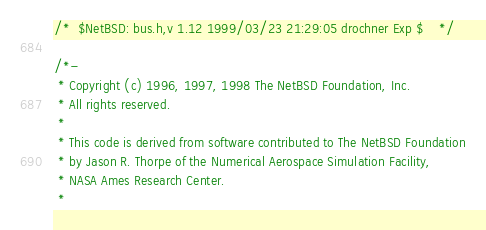Convert code to text. <code><loc_0><loc_0><loc_500><loc_500><_C_>/*	$NetBSD: bus.h,v 1.12 1999/03/23 21:29:05 drochner Exp $	*/

/*-
 * Copyright (c) 1996, 1997, 1998 The NetBSD Foundation, Inc.
 * All rights reserved.
 *
 * This code is derived from software contributed to The NetBSD Foundation
 * by Jason R. Thorpe of the Numerical Aerospace Simulation Facility,
 * NASA Ames Research Center.
 *</code> 